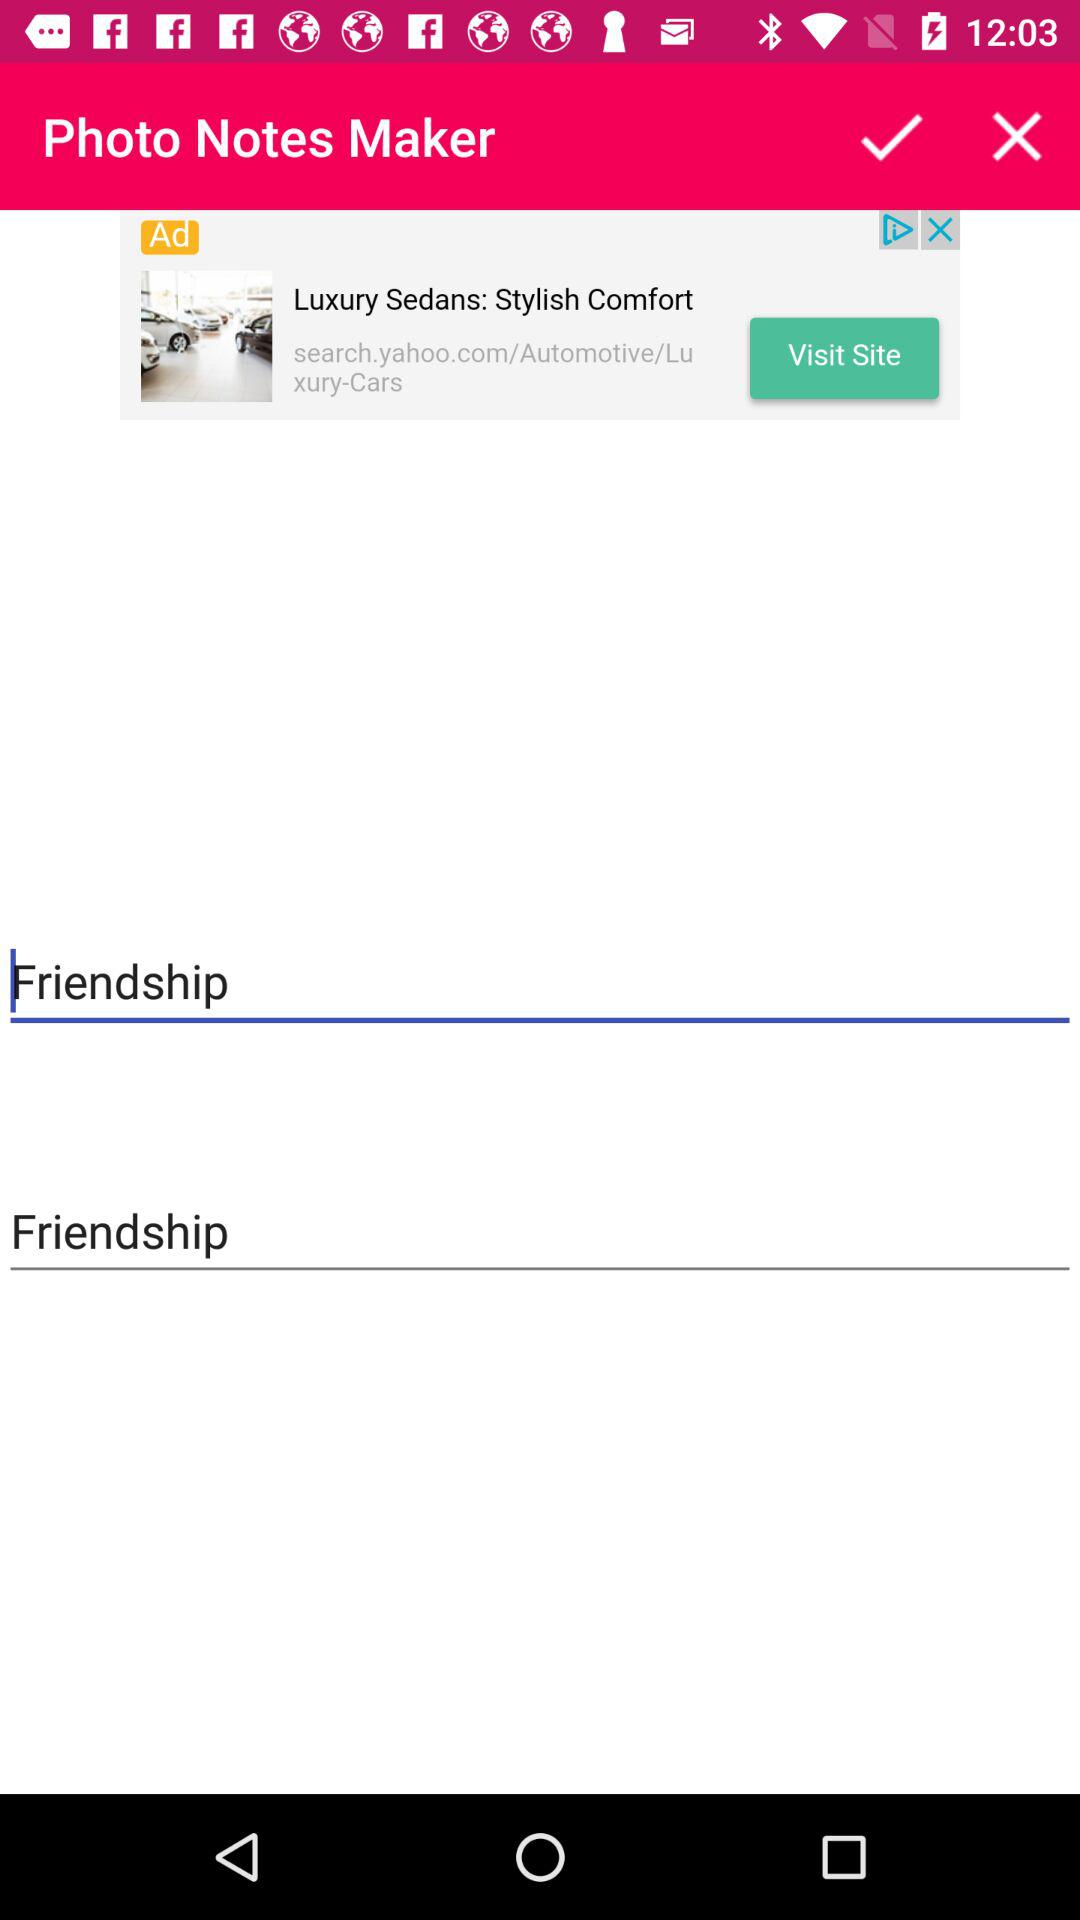How many notes are there?
Answer the question using a single word or phrase. 2 